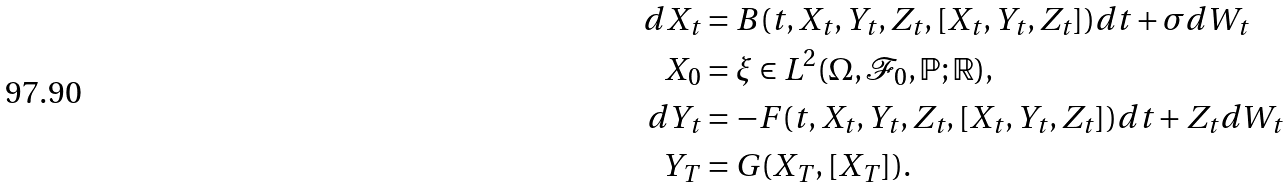Convert formula to latex. <formula><loc_0><loc_0><loc_500><loc_500>d X _ { t } & = B ( t , X _ { t } , Y _ { t } , Z _ { t } , [ X _ { t } , Y _ { t } , Z _ { t } ] ) d t + \sigma d W _ { t } \\ X _ { 0 } & = \xi \in L ^ { 2 } ( \Omega , \mathcal { F } _ { 0 } , \mathbb { P } ; \mathbb { R } ) , \\ d Y _ { t } & = - F ( t , X _ { t } , Y _ { t } , Z _ { t } , [ X _ { t } , Y _ { t } , Z _ { t } ] ) d t + Z _ { t } d W _ { t } \\ Y _ { T } & = G ( X _ { T } , [ X _ { T } ] ) . \\</formula> 